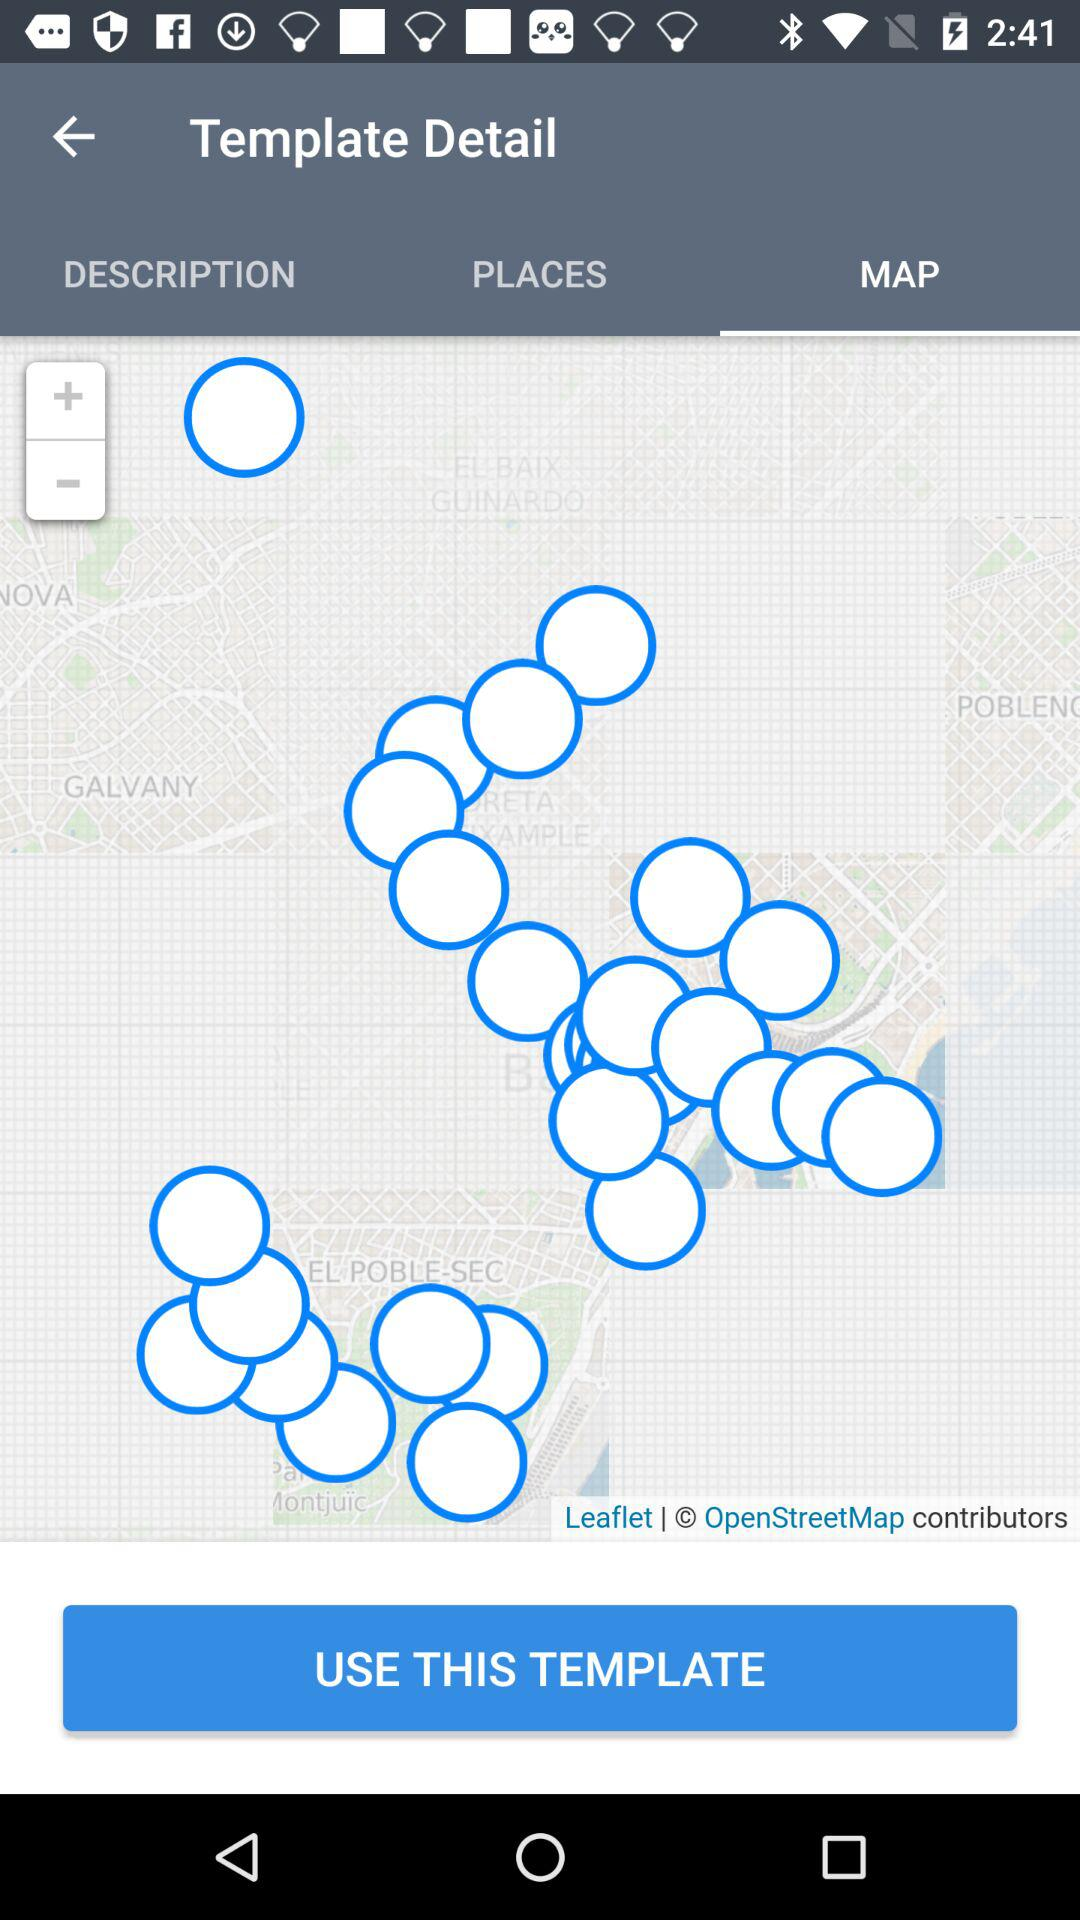Which tab is open? The open tab is "MAP". 